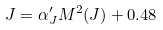<formula> <loc_0><loc_0><loc_500><loc_500>J = \alpha ^ { \prime } _ { J } M ^ { 2 } ( J ) + 0 . 4 8</formula> 